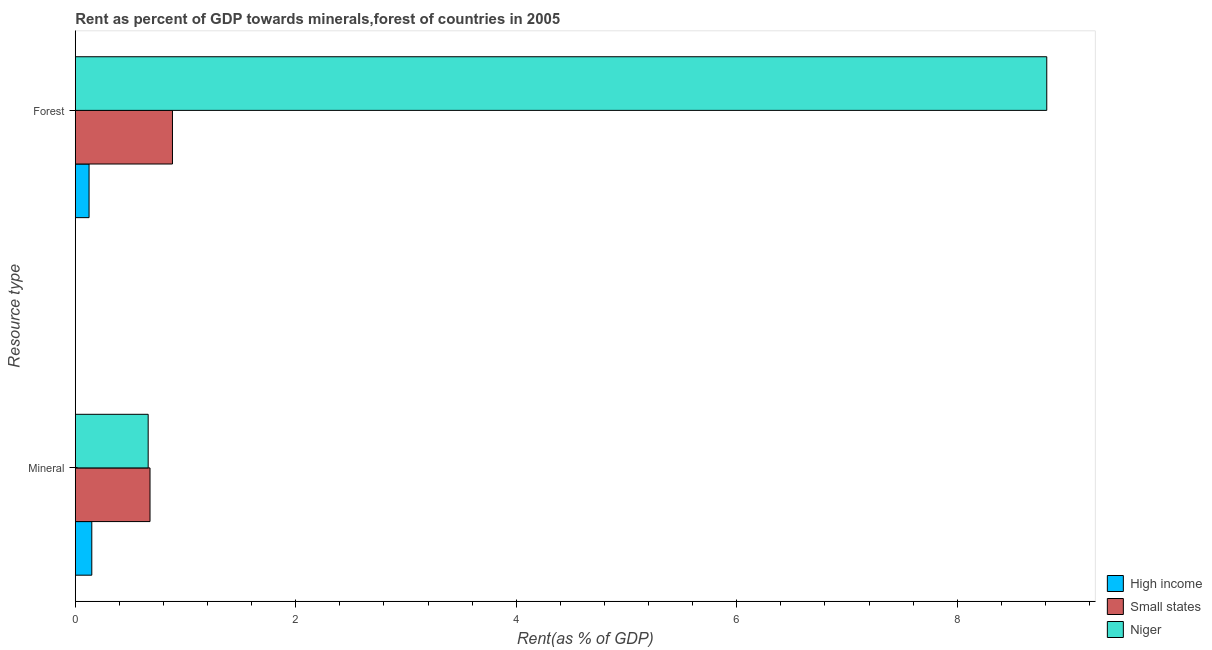How many bars are there on the 1st tick from the top?
Offer a very short reply. 3. What is the label of the 2nd group of bars from the top?
Give a very brief answer. Mineral. What is the forest rent in Niger?
Provide a short and direct response. 8.81. Across all countries, what is the maximum mineral rent?
Make the answer very short. 0.68. Across all countries, what is the minimum mineral rent?
Provide a succinct answer. 0.15. In which country was the mineral rent maximum?
Make the answer very short. Small states. In which country was the forest rent minimum?
Offer a very short reply. High income. What is the total forest rent in the graph?
Your answer should be compact. 9.82. What is the difference between the forest rent in Small states and that in Niger?
Your answer should be compact. -7.93. What is the difference between the mineral rent in Niger and the forest rent in High income?
Provide a short and direct response. 0.54. What is the average mineral rent per country?
Keep it short and to the point. 0.5. What is the difference between the mineral rent and forest rent in High income?
Ensure brevity in your answer.  0.02. In how many countries, is the forest rent greater than 8 %?
Keep it short and to the point. 1. What is the ratio of the forest rent in Niger to that in High income?
Provide a short and direct response. 70.56. What does the 2nd bar from the top in Forest represents?
Your response must be concise. Small states. How many bars are there?
Give a very brief answer. 6. Are all the bars in the graph horizontal?
Offer a terse response. Yes. How many countries are there in the graph?
Keep it short and to the point. 3. What is the difference between two consecutive major ticks on the X-axis?
Make the answer very short. 2. Are the values on the major ticks of X-axis written in scientific E-notation?
Provide a short and direct response. No. Does the graph contain any zero values?
Offer a very short reply. No. Does the graph contain grids?
Offer a very short reply. No. Where does the legend appear in the graph?
Offer a terse response. Bottom right. How many legend labels are there?
Provide a succinct answer. 3. How are the legend labels stacked?
Give a very brief answer. Vertical. What is the title of the graph?
Your response must be concise. Rent as percent of GDP towards minerals,forest of countries in 2005. What is the label or title of the X-axis?
Offer a terse response. Rent(as % of GDP). What is the label or title of the Y-axis?
Your response must be concise. Resource type. What is the Rent(as % of GDP) in High income in Mineral?
Give a very brief answer. 0.15. What is the Rent(as % of GDP) in Small states in Mineral?
Keep it short and to the point. 0.68. What is the Rent(as % of GDP) in Niger in Mineral?
Provide a succinct answer. 0.66. What is the Rent(as % of GDP) of High income in Forest?
Make the answer very short. 0.12. What is the Rent(as % of GDP) of Small states in Forest?
Your answer should be very brief. 0.88. What is the Rent(as % of GDP) of Niger in Forest?
Your answer should be very brief. 8.81. Across all Resource type, what is the maximum Rent(as % of GDP) in High income?
Your answer should be compact. 0.15. Across all Resource type, what is the maximum Rent(as % of GDP) of Small states?
Provide a short and direct response. 0.88. Across all Resource type, what is the maximum Rent(as % of GDP) in Niger?
Ensure brevity in your answer.  8.81. Across all Resource type, what is the minimum Rent(as % of GDP) in High income?
Your answer should be very brief. 0.12. Across all Resource type, what is the minimum Rent(as % of GDP) of Small states?
Your response must be concise. 0.68. Across all Resource type, what is the minimum Rent(as % of GDP) of Niger?
Your response must be concise. 0.66. What is the total Rent(as % of GDP) of High income in the graph?
Offer a very short reply. 0.27. What is the total Rent(as % of GDP) in Small states in the graph?
Offer a very short reply. 1.56. What is the total Rent(as % of GDP) of Niger in the graph?
Give a very brief answer. 9.47. What is the difference between the Rent(as % of GDP) in High income in Mineral and that in Forest?
Provide a succinct answer. 0.02. What is the difference between the Rent(as % of GDP) of Small states in Mineral and that in Forest?
Your answer should be compact. -0.2. What is the difference between the Rent(as % of GDP) of Niger in Mineral and that in Forest?
Your answer should be compact. -8.15. What is the difference between the Rent(as % of GDP) in High income in Mineral and the Rent(as % of GDP) in Small states in Forest?
Offer a very short reply. -0.73. What is the difference between the Rent(as % of GDP) in High income in Mineral and the Rent(as % of GDP) in Niger in Forest?
Your response must be concise. -8.66. What is the difference between the Rent(as % of GDP) in Small states in Mineral and the Rent(as % of GDP) in Niger in Forest?
Offer a very short reply. -8.13. What is the average Rent(as % of GDP) in High income per Resource type?
Offer a terse response. 0.14. What is the average Rent(as % of GDP) of Small states per Resource type?
Your answer should be very brief. 0.78. What is the average Rent(as % of GDP) in Niger per Resource type?
Provide a succinct answer. 4.74. What is the difference between the Rent(as % of GDP) in High income and Rent(as % of GDP) in Small states in Mineral?
Provide a short and direct response. -0.53. What is the difference between the Rent(as % of GDP) in High income and Rent(as % of GDP) in Niger in Mineral?
Give a very brief answer. -0.51. What is the difference between the Rent(as % of GDP) in Small states and Rent(as % of GDP) in Niger in Mineral?
Ensure brevity in your answer.  0.02. What is the difference between the Rent(as % of GDP) of High income and Rent(as % of GDP) of Small states in Forest?
Your answer should be very brief. -0.76. What is the difference between the Rent(as % of GDP) of High income and Rent(as % of GDP) of Niger in Forest?
Give a very brief answer. -8.69. What is the difference between the Rent(as % of GDP) of Small states and Rent(as % of GDP) of Niger in Forest?
Keep it short and to the point. -7.93. What is the ratio of the Rent(as % of GDP) of High income in Mineral to that in Forest?
Provide a short and direct response. 1.2. What is the ratio of the Rent(as % of GDP) in Small states in Mineral to that in Forest?
Provide a succinct answer. 0.77. What is the ratio of the Rent(as % of GDP) of Niger in Mineral to that in Forest?
Provide a succinct answer. 0.07. What is the difference between the highest and the second highest Rent(as % of GDP) in High income?
Your answer should be very brief. 0.02. What is the difference between the highest and the second highest Rent(as % of GDP) of Small states?
Offer a very short reply. 0.2. What is the difference between the highest and the second highest Rent(as % of GDP) of Niger?
Ensure brevity in your answer.  8.15. What is the difference between the highest and the lowest Rent(as % of GDP) of High income?
Your response must be concise. 0.02. What is the difference between the highest and the lowest Rent(as % of GDP) in Small states?
Your response must be concise. 0.2. What is the difference between the highest and the lowest Rent(as % of GDP) in Niger?
Make the answer very short. 8.15. 